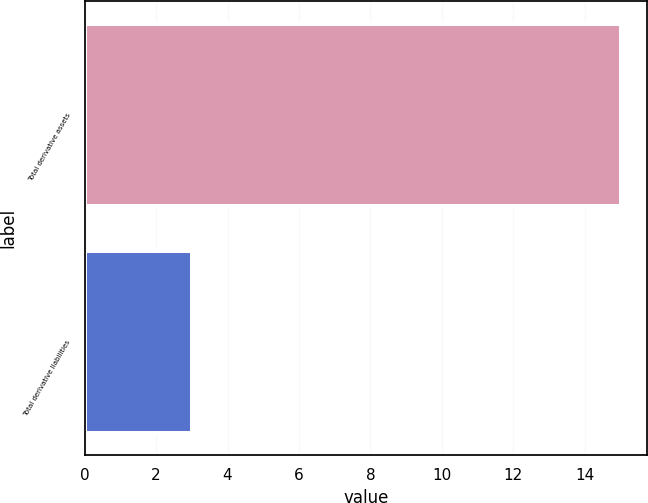Convert chart. <chart><loc_0><loc_0><loc_500><loc_500><bar_chart><fcel>Total derivative assets<fcel>Total derivative liabilities<nl><fcel>15<fcel>3<nl></chart> 